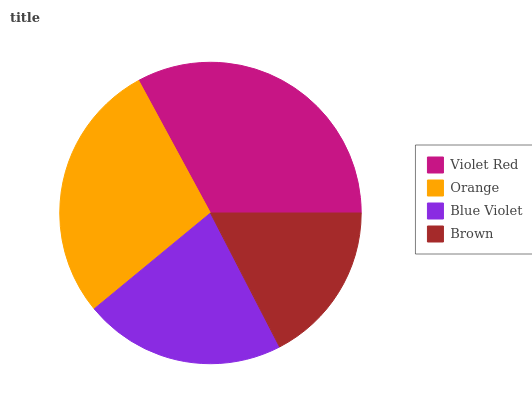Is Brown the minimum?
Answer yes or no. Yes. Is Violet Red the maximum?
Answer yes or no. Yes. Is Orange the minimum?
Answer yes or no. No. Is Orange the maximum?
Answer yes or no. No. Is Violet Red greater than Orange?
Answer yes or no. Yes. Is Orange less than Violet Red?
Answer yes or no. Yes. Is Orange greater than Violet Red?
Answer yes or no. No. Is Violet Red less than Orange?
Answer yes or no. No. Is Orange the high median?
Answer yes or no. Yes. Is Blue Violet the low median?
Answer yes or no. Yes. Is Blue Violet the high median?
Answer yes or no. No. Is Orange the low median?
Answer yes or no. No. 